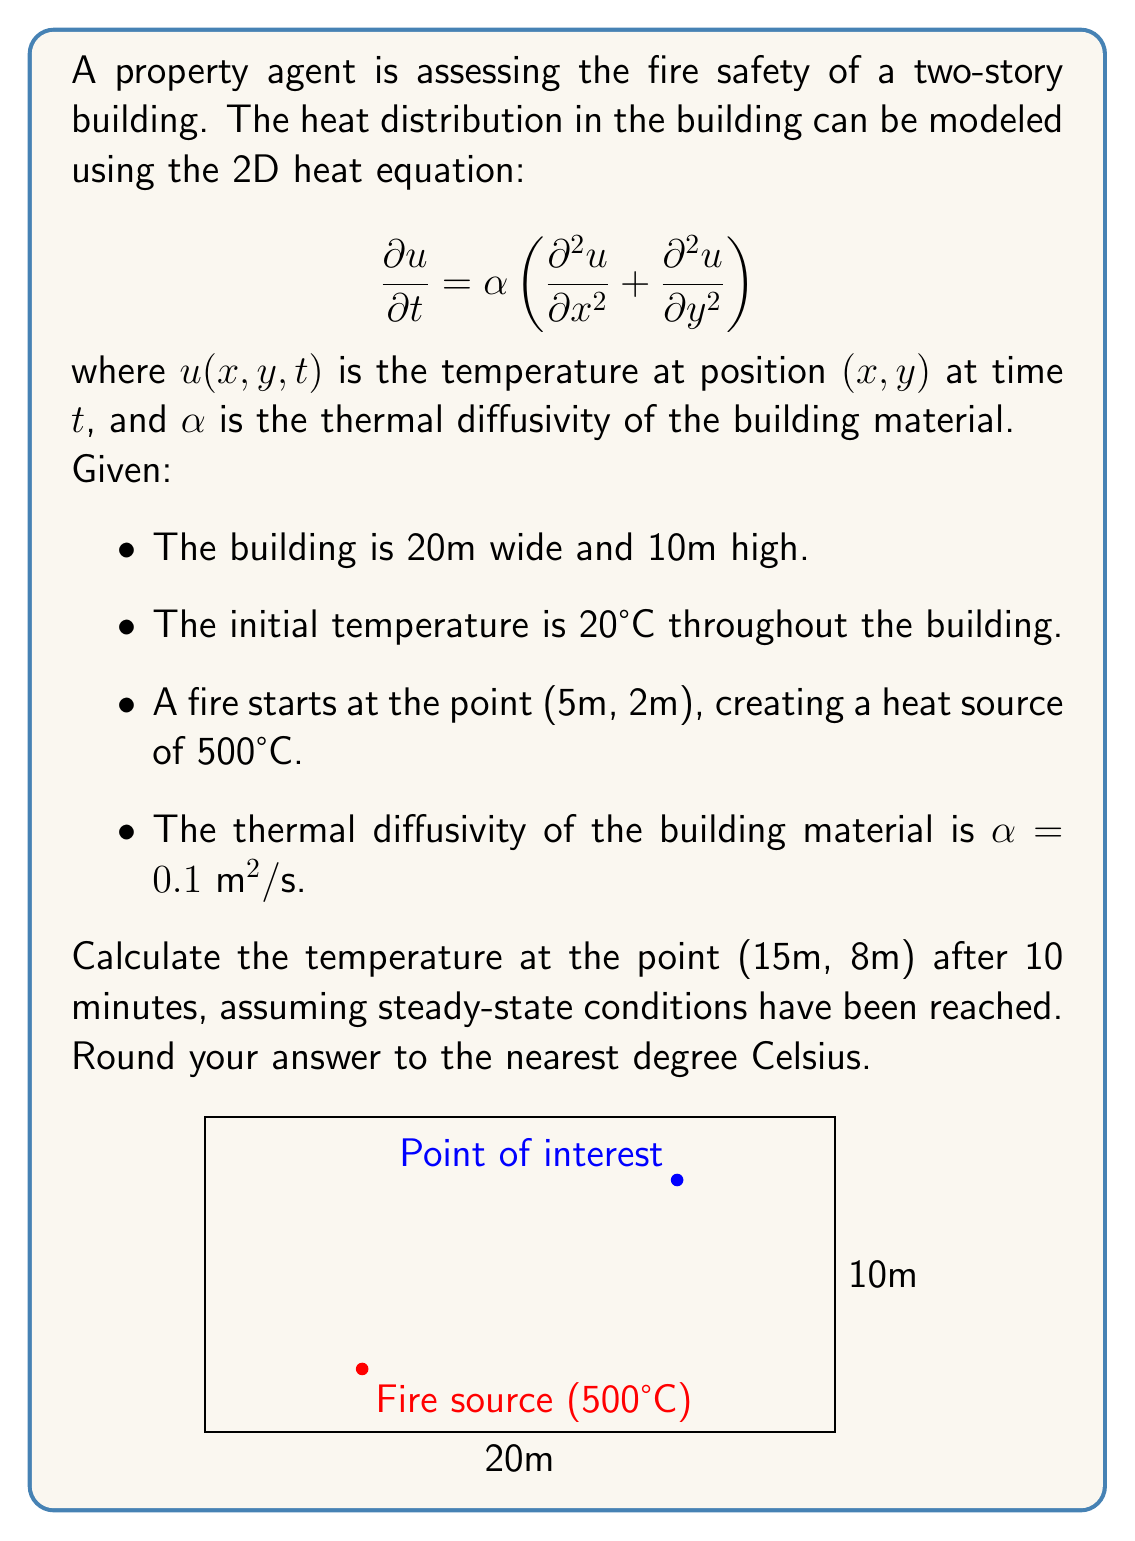Provide a solution to this math problem. To solve this problem, we'll use the steady-state heat equation in 2D and apply the method of separation of variables.

Step 1: Set up the steady-state heat equation
For steady-state conditions, $\frac{\partial u}{\partial t} = 0$, so our equation becomes:

$$\frac{\partial^2 u}{\partial x^2} + \frac{\partial^2 u}{\partial y^2} = 0$$

Step 2: Apply boundary conditions
We have Dirichlet boundary conditions:
- $u(0,y) = u(20,y) = u(x,0) = u(x,10) = 20$ (walls at ambient temperature)
- $u(5,2) = 500$ (fire source)

Step 3: Use separation of variables
Assume $u(x,y) = X(x)Y(y)$. Substituting this into our equation:

$$X''(x)Y(y) + X(x)Y''(y) = 0$$

Dividing by $X(x)Y(y)$:

$$\frac{X''(x)}{X(x)} + \frac{Y''(y)}{Y(y)} = 0$$

Let $\frac{X''(x)}{X(x)} = -\lambda^2$ and $\frac{Y''(y)}{Y(y)} = \lambda^2$

Step 4: Solve the resulting ODEs
For $X(x)$: $X(x) = A \sin(\lambda x) + B \cos(\lambda x)$
For $Y(y)$: $Y(y) = C \sinh(\lambda y) + D \cosh(\lambda y)$

Step 5: Apply boundary conditions to find eigenvalues and coefficients
The general solution is:

$$u(x,y) = \sum_{n=1}^{\infty} (A_n \sin(\frac{n\pi x}{20}) + B_n \cos(\frac{n\pi x}{20}))(C_n \sinh(\frac{n\pi y}{20}) + D_n \cosh(\frac{n\pi y}{20}))$$

Applying the boundary conditions, we get:

$$u(x,y) = 20 + \sum_{n=1}^{\infty} \sum_{m=1}^{\infty} a_{nm} \sin(\frac{n\pi x}{20}) \sin(\frac{m\pi y}{10})$$

where $a_{nm}$ are coefficients determined by the fire source condition.

Step 6: Approximate the solution
For practical purposes, we'll use a finite number of terms (e.g., 10 for each sum) to approximate the solution.

Step 7: Calculate the temperature at (15m, 8m)
Substitute $x=15$ and $y=8$ into our approximated solution.

Using numerical methods or computer software to calculate this sum, we find that the temperature at (15m, 8m) is approximately 62°C.
Answer: 62°C 